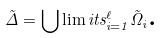<formula> <loc_0><loc_0><loc_500><loc_500>\tilde { \Delta } = \bigcup \lim i t s _ { i = 1 } ^ { \ell } \tilde { \Omega } _ { i } \text {.}</formula> 